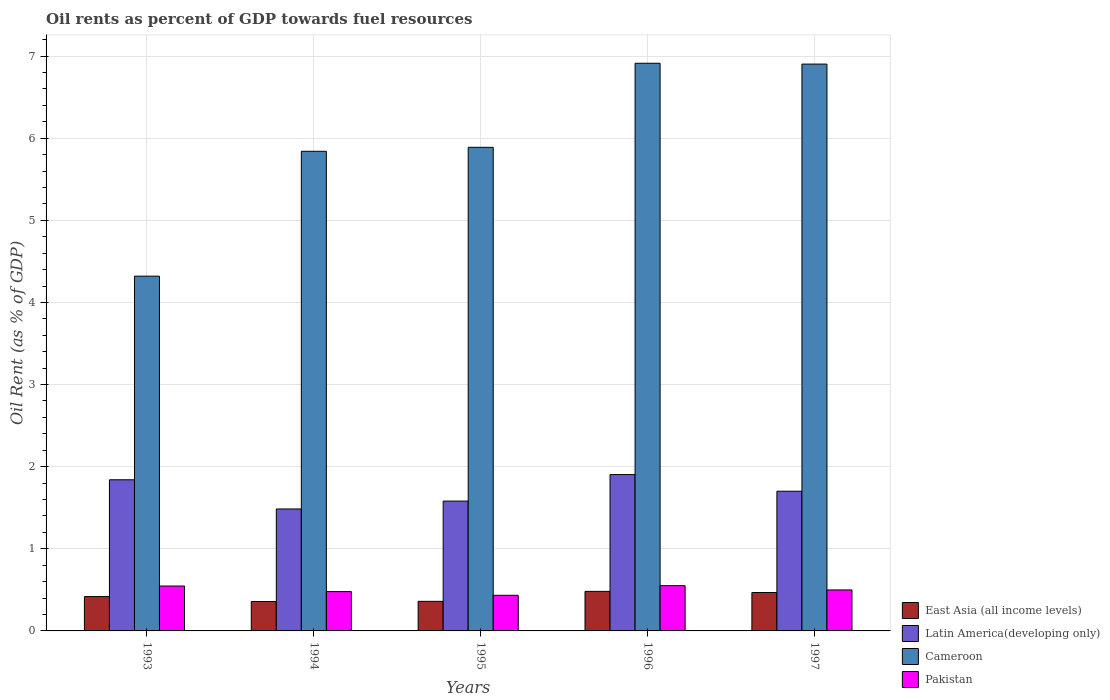How many different coloured bars are there?
Your answer should be very brief. 4. How many groups of bars are there?
Offer a terse response. 5. Are the number of bars per tick equal to the number of legend labels?
Provide a short and direct response. Yes. Are the number of bars on each tick of the X-axis equal?
Provide a short and direct response. Yes. How many bars are there on the 1st tick from the left?
Your answer should be compact. 4. What is the oil rent in Latin America(developing only) in 1993?
Ensure brevity in your answer.  1.84. Across all years, what is the maximum oil rent in East Asia (all income levels)?
Give a very brief answer. 0.48. Across all years, what is the minimum oil rent in East Asia (all income levels)?
Provide a succinct answer. 0.36. In which year was the oil rent in Latin America(developing only) maximum?
Give a very brief answer. 1996. In which year was the oil rent in Latin America(developing only) minimum?
Provide a succinct answer. 1994. What is the total oil rent in Pakistan in the graph?
Your answer should be very brief. 2.51. What is the difference between the oil rent in Cameroon in 1993 and that in 1994?
Your answer should be very brief. -1.52. What is the difference between the oil rent in East Asia (all income levels) in 1997 and the oil rent in Pakistan in 1996?
Keep it short and to the point. -0.08. What is the average oil rent in Pakistan per year?
Offer a terse response. 0.5. In the year 1996, what is the difference between the oil rent in Latin America(developing only) and oil rent in Cameroon?
Offer a very short reply. -5.01. In how many years, is the oil rent in East Asia (all income levels) greater than 6.2 %?
Keep it short and to the point. 0. What is the ratio of the oil rent in Latin America(developing only) in 1993 to that in 1994?
Your answer should be compact. 1.24. Is the difference between the oil rent in Latin America(developing only) in 1995 and 1997 greater than the difference between the oil rent in Cameroon in 1995 and 1997?
Keep it short and to the point. Yes. What is the difference between the highest and the second highest oil rent in Latin America(developing only)?
Give a very brief answer. 0.06. What is the difference between the highest and the lowest oil rent in East Asia (all income levels)?
Make the answer very short. 0.12. What does the 3rd bar from the left in 1997 represents?
Your answer should be compact. Cameroon. What does the 2nd bar from the right in 1993 represents?
Your answer should be very brief. Cameroon. Is it the case that in every year, the sum of the oil rent in Pakistan and oil rent in Latin America(developing only) is greater than the oil rent in Cameroon?
Give a very brief answer. No. How many bars are there?
Keep it short and to the point. 20. Are all the bars in the graph horizontal?
Give a very brief answer. No. What is the difference between two consecutive major ticks on the Y-axis?
Your answer should be compact. 1. Are the values on the major ticks of Y-axis written in scientific E-notation?
Offer a terse response. No. What is the title of the graph?
Your answer should be compact. Oil rents as percent of GDP towards fuel resources. What is the label or title of the X-axis?
Ensure brevity in your answer.  Years. What is the label or title of the Y-axis?
Offer a very short reply. Oil Rent (as % of GDP). What is the Oil Rent (as % of GDP) in East Asia (all income levels) in 1993?
Provide a short and direct response. 0.42. What is the Oil Rent (as % of GDP) in Latin America(developing only) in 1993?
Ensure brevity in your answer.  1.84. What is the Oil Rent (as % of GDP) in Cameroon in 1993?
Give a very brief answer. 4.32. What is the Oil Rent (as % of GDP) of Pakistan in 1993?
Ensure brevity in your answer.  0.55. What is the Oil Rent (as % of GDP) of East Asia (all income levels) in 1994?
Give a very brief answer. 0.36. What is the Oil Rent (as % of GDP) of Latin America(developing only) in 1994?
Your answer should be very brief. 1.49. What is the Oil Rent (as % of GDP) in Cameroon in 1994?
Provide a succinct answer. 5.84. What is the Oil Rent (as % of GDP) of Pakistan in 1994?
Offer a terse response. 0.48. What is the Oil Rent (as % of GDP) of East Asia (all income levels) in 1995?
Give a very brief answer. 0.36. What is the Oil Rent (as % of GDP) in Latin America(developing only) in 1995?
Provide a succinct answer. 1.58. What is the Oil Rent (as % of GDP) in Cameroon in 1995?
Your answer should be compact. 5.89. What is the Oil Rent (as % of GDP) in Pakistan in 1995?
Your answer should be compact. 0.43. What is the Oil Rent (as % of GDP) of East Asia (all income levels) in 1996?
Provide a succinct answer. 0.48. What is the Oil Rent (as % of GDP) in Latin America(developing only) in 1996?
Make the answer very short. 1.9. What is the Oil Rent (as % of GDP) of Cameroon in 1996?
Provide a succinct answer. 6.91. What is the Oil Rent (as % of GDP) of Pakistan in 1996?
Provide a succinct answer. 0.55. What is the Oil Rent (as % of GDP) of East Asia (all income levels) in 1997?
Provide a short and direct response. 0.47. What is the Oil Rent (as % of GDP) of Latin America(developing only) in 1997?
Your answer should be compact. 1.7. What is the Oil Rent (as % of GDP) of Cameroon in 1997?
Ensure brevity in your answer.  6.9. What is the Oil Rent (as % of GDP) in Pakistan in 1997?
Give a very brief answer. 0.5. Across all years, what is the maximum Oil Rent (as % of GDP) in East Asia (all income levels)?
Your answer should be compact. 0.48. Across all years, what is the maximum Oil Rent (as % of GDP) of Latin America(developing only)?
Provide a succinct answer. 1.9. Across all years, what is the maximum Oil Rent (as % of GDP) of Cameroon?
Your answer should be very brief. 6.91. Across all years, what is the maximum Oil Rent (as % of GDP) of Pakistan?
Give a very brief answer. 0.55. Across all years, what is the minimum Oil Rent (as % of GDP) in East Asia (all income levels)?
Your answer should be very brief. 0.36. Across all years, what is the minimum Oil Rent (as % of GDP) of Latin America(developing only)?
Your answer should be very brief. 1.49. Across all years, what is the minimum Oil Rent (as % of GDP) in Cameroon?
Your answer should be very brief. 4.32. Across all years, what is the minimum Oil Rent (as % of GDP) in Pakistan?
Your answer should be very brief. 0.43. What is the total Oil Rent (as % of GDP) of East Asia (all income levels) in the graph?
Your answer should be very brief. 2.09. What is the total Oil Rent (as % of GDP) in Latin America(developing only) in the graph?
Your response must be concise. 8.51. What is the total Oil Rent (as % of GDP) of Cameroon in the graph?
Make the answer very short. 29.86. What is the total Oil Rent (as % of GDP) of Pakistan in the graph?
Offer a very short reply. 2.51. What is the difference between the Oil Rent (as % of GDP) in East Asia (all income levels) in 1993 and that in 1994?
Provide a succinct answer. 0.06. What is the difference between the Oil Rent (as % of GDP) in Latin America(developing only) in 1993 and that in 1994?
Provide a succinct answer. 0.36. What is the difference between the Oil Rent (as % of GDP) in Cameroon in 1993 and that in 1994?
Provide a succinct answer. -1.52. What is the difference between the Oil Rent (as % of GDP) of Pakistan in 1993 and that in 1994?
Make the answer very short. 0.07. What is the difference between the Oil Rent (as % of GDP) of East Asia (all income levels) in 1993 and that in 1995?
Keep it short and to the point. 0.06. What is the difference between the Oil Rent (as % of GDP) of Latin America(developing only) in 1993 and that in 1995?
Your answer should be compact. 0.26. What is the difference between the Oil Rent (as % of GDP) in Cameroon in 1993 and that in 1995?
Ensure brevity in your answer.  -1.57. What is the difference between the Oil Rent (as % of GDP) of Pakistan in 1993 and that in 1995?
Your answer should be very brief. 0.11. What is the difference between the Oil Rent (as % of GDP) in East Asia (all income levels) in 1993 and that in 1996?
Provide a short and direct response. -0.06. What is the difference between the Oil Rent (as % of GDP) in Latin America(developing only) in 1993 and that in 1996?
Make the answer very short. -0.06. What is the difference between the Oil Rent (as % of GDP) of Cameroon in 1993 and that in 1996?
Offer a terse response. -2.59. What is the difference between the Oil Rent (as % of GDP) in Pakistan in 1993 and that in 1996?
Make the answer very short. -0. What is the difference between the Oil Rent (as % of GDP) of East Asia (all income levels) in 1993 and that in 1997?
Ensure brevity in your answer.  -0.05. What is the difference between the Oil Rent (as % of GDP) of Latin America(developing only) in 1993 and that in 1997?
Give a very brief answer. 0.14. What is the difference between the Oil Rent (as % of GDP) in Cameroon in 1993 and that in 1997?
Make the answer very short. -2.58. What is the difference between the Oil Rent (as % of GDP) in Pakistan in 1993 and that in 1997?
Provide a succinct answer. 0.05. What is the difference between the Oil Rent (as % of GDP) in East Asia (all income levels) in 1994 and that in 1995?
Give a very brief answer. -0. What is the difference between the Oil Rent (as % of GDP) of Latin America(developing only) in 1994 and that in 1995?
Ensure brevity in your answer.  -0.1. What is the difference between the Oil Rent (as % of GDP) of Cameroon in 1994 and that in 1995?
Give a very brief answer. -0.05. What is the difference between the Oil Rent (as % of GDP) in Pakistan in 1994 and that in 1995?
Provide a succinct answer. 0.04. What is the difference between the Oil Rent (as % of GDP) of East Asia (all income levels) in 1994 and that in 1996?
Offer a very short reply. -0.12. What is the difference between the Oil Rent (as % of GDP) of Latin America(developing only) in 1994 and that in 1996?
Offer a very short reply. -0.42. What is the difference between the Oil Rent (as % of GDP) of Cameroon in 1994 and that in 1996?
Keep it short and to the point. -1.07. What is the difference between the Oil Rent (as % of GDP) of Pakistan in 1994 and that in 1996?
Offer a very short reply. -0.07. What is the difference between the Oil Rent (as % of GDP) in East Asia (all income levels) in 1994 and that in 1997?
Your answer should be compact. -0.11. What is the difference between the Oil Rent (as % of GDP) in Latin America(developing only) in 1994 and that in 1997?
Keep it short and to the point. -0.22. What is the difference between the Oil Rent (as % of GDP) of Cameroon in 1994 and that in 1997?
Your response must be concise. -1.06. What is the difference between the Oil Rent (as % of GDP) in Pakistan in 1994 and that in 1997?
Your response must be concise. -0.02. What is the difference between the Oil Rent (as % of GDP) of East Asia (all income levels) in 1995 and that in 1996?
Ensure brevity in your answer.  -0.12. What is the difference between the Oil Rent (as % of GDP) of Latin America(developing only) in 1995 and that in 1996?
Provide a short and direct response. -0.32. What is the difference between the Oil Rent (as % of GDP) in Cameroon in 1995 and that in 1996?
Provide a short and direct response. -1.02. What is the difference between the Oil Rent (as % of GDP) of Pakistan in 1995 and that in 1996?
Ensure brevity in your answer.  -0.12. What is the difference between the Oil Rent (as % of GDP) of East Asia (all income levels) in 1995 and that in 1997?
Offer a terse response. -0.11. What is the difference between the Oil Rent (as % of GDP) in Latin America(developing only) in 1995 and that in 1997?
Offer a very short reply. -0.12. What is the difference between the Oil Rent (as % of GDP) in Cameroon in 1995 and that in 1997?
Your response must be concise. -1.01. What is the difference between the Oil Rent (as % of GDP) of Pakistan in 1995 and that in 1997?
Your response must be concise. -0.07. What is the difference between the Oil Rent (as % of GDP) of East Asia (all income levels) in 1996 and that in 1997?
Offer a terse response. 0.01. What is the difference between the Oil Rent (as % of GDP) of Latin America(developing only) in 1996 and that in 1997?
Give a very brief answer. 0.2. What is the difference between the Oil Rent (as % of GDP) in Cameroon in 1996 and that in 1997?
Your response must be concise. 0.01. What is the difference between the Oil Rent (as % of GDP) in Pakistan in 1996 and that in 1997?
Make the answer very short. 0.05. What is the difference between the Oil Rent (as % of GDP) of East Asia (all income levels) in 1993 and the Oil Rent (as % of GDP) of Latin America(developing only) in 1994?
Offer a terse response. -1.07. What is the difference between the Oil Rent (as % of GDP) in East Asia (all income levels) in 1993 and the Oil Rent (as % of GDP) in Cameroon in 1994?
Provide a succinct answer. -5.42. What is the difference between the Oil Rent (as % of GDP) in East Asia (all income levels) in 1993 and the Oil Rent (as % of GDP) in Pakistan in 1994?
Provide a succinct answer. -0.06. What is the difference between the Oil Rent (as % of GDP) in Latin America(developing only) in 1993 and the Oil Rent (as % of GDP) in Cameroon in 1994?
Your answer should be compact. -4. What is the difference between the Oil Rent (as % of GDP) in Latin America(developing only) in 1993 and the Oil Rent (as % of GDP) in Pakistan in 1994?
Your answer should be very brief. 1.36. What is the difference between the Oil Rent (as % of GDP) in Cameroon in 1993 and the Oil Rent (as % of GDP) in Pakistan in 1994?
Ensure brevity in your answer.  3.84. What is the difference between the Oil Rent (as % of GDP) of East Asia (all income levels) in 1993 and the Oil Rent (as % of GDP) of Latin America(developing only) in 1995?
Keep it short and to the point. -1.16. What is the difference between the Oil Rent (as % of GDP) in East Asia (all income levels) in 1993 and the Oil Rent (as % of GDP) in Cameroon in 1995?
Your response must be concise. -5.47. What is the difference between the Oil Rent (as % of GDP) in East Asia (all income levels) in 1993 and the Oil Rent (as % of GDP) in Pakistan in 1995?
Your answer should be very brief. -0.02. What is the difference between the Oil Rent (as % of GDP) of Latin America(developing only) in 1993 and the Oil Rent (as % of GDP) of Cameroon in 1995?
Your response must be concise. -4.05. What is the difference between the Oil Rent (as % of GDP) of Latin America(developing only) in 1993 and the Oil Rent (as % of GDP) of Pakistan in 1995?
Ensure brevity in your answer.  1.41. What is the difference between the Oil Rent (as % of GDP) of Cameroon in 1993 and the Oil Rent (as % of GDP) of Pakistan in 1995?
Make the answer very short. 3.89. What is the difference between the Oil Rent (as % of GDP) in East Asia (all income levels) in 1993 and the Oil Rent (as % of GDP) in Latin America(developing only) in 1996?
Provide a short and direct response. -1.49. What is the difference between the Oil Rent (as % of GDP) in East Asia (all income levels) in 1993 and the Oil Rent (as % of GDP) in Cameroon in 1996?
Your answer should be compact. -6.49. What is the difference between the Oil Rent (as % of GDP) of East Asia (all income levels) in 1993 and the Oil Rent (as % of GDP) of Pakistan in 1996?
Offer a terse response. -0.13. What is the difference between the Oil Rent (as % of GDP) of Latin America(developing only) in 1993 and the Oil Rent (as % of GDP) of Cameroon in 1996?
Offer a very short reply. -5.07. What is the difference between the Oil Rent (as % of GDP) in Latin America(developing only) in 1993 and the Oil Rent (as % of GDP) in Pakistan in 1996?
Offer a terse response. 1.29. What is the difference between the Oil Rent (as % of GDP) of Cameroon in 1993 and the Oil Rent (as % of GDP) of Pakistan in 1996?
Your answer should be compact. 3.77. What is the difference between the Oil Rent (as % of GDP) in East Asia (all income levels) in 1993 and the Oil Rent (as % of GDP) in Latin America(developing only) in 1997?
Your answer should be compact. -1.28. What is the difference between the Oil Rent (as % of GDP) in East Asia (all income levels) in 1993 and the Oil Rent (as % of GDP) in Cameroon in 1997?
Provide a succinct answer. -6.48. What is the difference between the Oil Rent (as % of GDP) in East Asia (all income levels) in 1993 and the Oil Rent (as % of GDP) in Pakistan in 1997?
Make the answer very short. -0.08. What is the difference between the Oil Rent (as % of GDP) of Latin America(developing only) in 1993 and the Oil Rent (as % of GDP) of Cameroon in 1997?
Give a very brief answer. -5.06. What is the difference between the Oil Rent (as % of GDP) in Latin America(developing only) in 1993 and the Oil Rent (as % of GDP) in Pakistan in 1997?
Keep it short and to the point. 1.34. What is the difference between the Oil Rent (as % of GDP) in Cameroon in 1993 and the Oil Rent (as % of GDP) in Pakistan in 1997?
Give a very brief answer. 3.82. What is the difference between the Oil Rent (as % of GDP) of East Asia (all income levels) in 1994 and the Oil Rent (as % of GDP) of Latin America(developing only) in 1995?
Your response must be concise. -1.22. What is the difference between the Oil Rent (as % of GDP) of East Asia (all income levels) in 1994 and the Oil Rent (as % of GDP) of Cameroon in 1995?
Provide a short and direct response. -5.53. What is the difference between the Oil Rent (as % of GDP) of East Asia (all income levels) in 1994 and the Oil Rent (as % of GDP) of Pakistan in 1995?
Ensure brevity in your answer.  -0.08. What is the difference between the Oil Rent (as % of GDP) of Latin America(developing only) in 1994 and the Oil Rent (as % of GDP) of Cameroon in 1995?
Your response must be concise. -4.4. What is the difference between the Oil Rent (as % of GDP) in Latin America(developing only) in 1994 and the Oil Rent (as % of GDP) in Pakistan in 1995?
Offer a very short reply. 1.05. What is the difference between the Oil Rent (as % of GDP) of Cameroon in 1994 and the Oil Rent (as % of GDP) of Pakistan in 1995?
Provide a succinct answer. 5.41. What is the difference between the Oil Rent (as % of GDP) of East Asia (all income levels) in 1994 and the Oil Rent (as % of GDP) of Latin America(developing only) in 1996?
Your answer should be compact. -1.55. What is the difference between the Oil Rent (as % of GDP) of East Asia (all income levels) in 1994 and the Oil Rent (as % of GDP) of Cameroon in 1996?
Your answer should be compact. -6.55. What is the difference between the Oil Rent (as % of GDP) in East Asia (all income levels) in 1994 and the Oil Rent (as % of GDP) in Pakistan in 1996?
Your answer should be very brief. -0.19. What is the difference between the Oil Rent (as % of GDP) in Latin America(developing only) in 1994 and the Oil Rent (as % of GDP) in Cameroon in 1996?
Your response must be concise. -5.43. What is the difference between the Oil Rent (as % of GDP) of Latin America(developing only) in 1994 and the Oil Rent (as % of GDP) of Pakistan in 1996?
Provide a short and direct response. 0.93. What is the difference between the Oil Rent (as % of GDP) in Cameroon in 1994 and the Oil Rent (as % of GDP) in Pakistan in 1996?
Your response must be concise. 5.29. What is the difference between the Oil Rent (as % of GDP) of East Asia (all income levels) in 1994 and the Oil Rent (as % of GDP) of Latin America(developing only) in 1997?
Provide a short and direct response. -1.34. What is the difference between the Oil Rent (as % of GDP) of East Asia (all income levels) in 1994 and the Oil Rent (as % of GDP) of Cameroon in 1997?
Offer a very short reply. -6.54. What is the difference between the Oil Rent (as % of GDP) in East Asia (all income levels) in 1994 and the Oil Rent (as % of GDP) in Pakistan in 1997?
Provide a succinct answer. -0.14. What is the difference between the Oil Rent (as % of GDP) of Latin America(developing only) in 1994 and the Oil Rent (as % of GDP) of Cameroon in 1997?
Keep it short and to the point. -5.42. What is the difference between the Oil Rent (as % of GDP) of Latin America(developing only) in 1994 and the Oil Rent (as % of GDP) of Pakistan in 1997?
Your answer should be compact. 0.99. What is the difference between the Oil Rent (as % of GDP) in Cameroon in 1994 and the Oil Rent (as % of GDP) in Pakistan in 1997?
Give a very brief answer. 5.34. What is the difference between the Oil Rent (as % of GDP) in East Asia (all income levels) in 1995 and the Oil Rent (as % of GDP) in Latin America(developing only) in 1996?
Offer a very short reply. -1.54. What is the difference between the Oil Rent (as % of GDP) in East Asia (all income levels) in 1995 and the Oil Rent (as % of GDP) in Cameroon in 1996?
Make the answer very short. -6.55. What is the difference between the Oil Rent (as % of GDP) of East Asia (all income levels) in 1995 and the Oil Rent (as % of GDP) of Pakistan in 1996?
Your answer should be compact. -0.19. What is the difference between the Oil Rent (as % of GDP) in Latin America(developing only) in 1995 and the Oil Rent (as % of GDP) in Cameroon in 1996?
Your answer should be very brief. -5.33. What is the difference between the Oil Rent (as % of GDP) in Latin America(developing only) in 1995 and the Oil Rent (as % of GDP) in Pakistan in 1996?
Provide a short and direct response. 1.03. What is the difference between the Oil Rent (as % of GDP) of Cameroon in 1995 and the Oil Rent (as % of GDP) of Pakistan in 1996?
Your answer should be compact. 5.34. What is the difference between the Oil Rent (as % of GDP) of East Asia (all income levels) in 1995 and the Oil Rent (as % of GDP) of Latin America(developing only) in 1997?
Your answer should be very brief. -1.34. What is the difference between the Oil Rent (as % of GDP) in East Asia (all income levels) in 1995 and the Oil Rent (as % of GDP) in Cameroon in 1997?
Provide a short and direct response. -6.54. What is the difference between the Oil Rent (as % of GDP) in East Asia (all income levels) in 1995 and the Oil Rent (as % of GDP) in Pakistan in 1997?
Your answer should be very brief. -0.14. What is the difference between the Oil Rent (as % of GDP) in Latin America(developing only) in 1995 and the Oil Rent (as % of GDP) in Cameroon in 1997?
Your response must be concise. -5.32. What is the difference between the Oil Rent (as % of GDP) in Latin America(developing only) in 1995 and the Oil Rent (as % of GDP) in Pakistan in 1997?
Your response must be concise. 1.08. What is the difference between the Oil Rent (as % of GDP) of Cameroon in 1995 and the Oil Rent (as % of GDP) of Pakistan in 1997?
Make the answer very short. 5.39. What is the difference between the Oil Rent (as % of GDP) of East Asia (all income levels) in 1996 and the Oil Rent (as % of GDP) of Latin America(developing only) in 1997?
Your response must be concise. -1.22. What is the difference between the Oil Rent (as % of GDP) of East Asia (all income levels) in 1996 and the Oil Rent (as % of GDP) of Cameroon in 1997?
Ensure brevity in your answer.  -6.42. What is the difference between the Oil Rent (as % of GDP) in East Asia (all income levels) in 1996 and the Oil Rent (as % of GDP) in Pakistan in 1997?
Provide a short and direct response. -0.02. What is the difference between the Oil Rent (as % of GDP) in Latin America(developing only) in 1996 and the Oil Rent (as % of GDP) in Cameroon in 1997?
Give a very brief answer. -5. What is the difference between the Oil Rent (as % of GDP) in Latin America(developing only) in 1996 and the Oil Rent (as % of GDP) in Pakistan in 1997?
Offer a terse response. 1.4. What is the difference between the Oil Rent (as % of GDP) of Cameroon in 1996 and the Oil Rent (as % of GDP) of Pakistan in 1997?
Your answer should be very brief. 6.41. What is the average Oil Rent (as % of GDP) of East Asia (all income levels) per year?
Your response must be concise. 0.42. What is the average Oil Rent (as % of GDP) of Latin America(developing only) per year?
Your answer should be very brief. 1.7. What is the average Oil Rent (as % of GDP) of Cameroon per year?
Provide a short and direct response. 5.97. What is the average Oil Rent (as % of GDP) of Pakistan per year?
Make the answer very short. 0.5. In the year 1993, what is the difference between the Oil Rent (as % of GDP) of East Asia (all income levels) and Oil Rent (as % of GDP) of Latin America(developing only)?
Offer a very short reply. -1.42. In the year 1993, what is the difference between the Oil Rent (as % of GDP) of East Asia (all income levels) and Oil Rent (as % of GDP) of Cameroon?
Provide a short and direct response. -3.9. In the year 1993, what is the difference between the Oil Rent (as % of GDP) of East Asia (all income levels) and Oil Rent (as % of GDP) of Pakistan?
Provide a short and direct response. -0.13. In the year 1993, what is the difference between the Oil Rent (as % of GDP) of Latin America(developing only) and Oil Rent (as % of GDP) of Cameroon?
Your answer should be very brief. -2.48. In the year 1993, what is the difference between the Oil Rent (as % of GDP) of Latin America(developing only) and Oil Rent (as % of GDP) of Pakistan?
Your response must be concise. 1.29. In the year 1993, what is the difference between the Oil Rent (as % of GDP) of Cameroon and Oil Rent (as % of GDP) of Pakistan?
Your answer should be very brief. 3.77. In the year 1994, what is the difference between the Oil Rent (as % of GDP) in East Asia (all income levels) and Oil Rent (as % of GDP) in Latin America(developing only)?
Keep it short and to the point. -1.13. In the year 1994, what is the difference between the Oil Rent (as % of GDP) of East Asia (all income levels) and Oil Rent (as % of GDP) of Cameroon?
Ensure brevity in your answer.  -5.48. In the year 1994, what is the difference between the Oil Rent (as % of GDP) of East Asia (all income levels) and Oil Rent (as % of GDP) of Pakistan?
Offer a terse response. -0.12. In the year 1994, what is the difference between the Oil Rent (as % of GDP) of Latin America(developing only) and Oil Rent (as % of GDP) of Cameroon?
Your answer should be compact. -4.36. In the year 1994, what is the difference between the Oil Rent (as % of GDP) in Latin America(developing only) and Oil Rent (as % of GDP) in Pakistan?
Your answer should be compact. 1.01. In the year 1994, what is the difference between the Oil Rent (as % of GDP) in Cameroon and Oil Rent (as % of GDP) in Pakistan?
Your answer should be compact. 5.36. In the year 1995, what is the difference between the Oil Rent (as % of GDP) of East Asia (all income levels) and Oil Rent (as % of GDP) of Latin America(developing only)?
Your response must be concise. -1.22. In the year 1995, what is the difference between the Oil Rent (as % of GDP) in East Asia (all income levels) and Oil Rent (as % of GDP) in Cameroon?
Offer a very short reply. -5.53. In the year 1995, what is the difference between the Oil Rent (as % of GDP) of East Asia (all income levels) and Oil Rent (as % of GDP) of Pakistan?
Offer a very short reply. -0.07. In the year 1995, what is the difference between the Oil Rent (as % of GDP) in Latin America(developing only) and Oil Rent (as % of GDP) in Cameroon?
Keep it short and to the point. -4.31. In the year 1995, what is the difference between the Oil Rent (as % of GDP) in Latin America(developing only) and Oil Rent (as % of GDP) in Pakistan?
Your answer should be compact. 1.15. In the year 1995, what is the difference between the Oil Rent (as % of GDP) of Cameroon and Oil Rent (as % of GDP) of Pakistan?
Keep it short and to the point. 5.45. In the year 1996, what is the difference between the Oil Rent (as % of GDP) in East Asia (all income levels) and Oil Rent (as % of GDP) in Latin America(developing only)?
Provide a succinct answer. -1.42. In the year 1996, what is the difference between the Oil Rent (as % of GDP) in East Asia (all income levels) and Oil Rent (as % of GDP) in Cameroon?
Give a very brief answer. -6.43. In the year 1996, what is the difference between the Oil Rent (as % of GDP) of East Asia (all income levels) and Oil Rent (as % of GDP) of Pakistan?
Your response must be concise. -0.07. In the year 1996, what is the difference between the Oil Rent (as % of GDP) in Latin America(developing only) and Oil Rent (as % of GDP) in Cameroon?
Make the answer very short. -5.01. In the year 1996, what is the difference between the Oil Rent (as % of GDP) of Latin America(developing only) and Oil Rent (as % of GDP) of Pakistan?
Provide a succinct answer. 1.35. In the year 1996, what is the difference between the Oil Rent (as % of GDP) of Cameroon and Oil Rent (as % of GDP) of Pakistan?
Keep it short and to the point. 6.36. In the year 1997, what is the difference between the Oil Rent (as % of GDP) in East Asia (all income levels) and Oil Rent (as % of GDP) in Latin America(developing only)?
Your answer should be very brief. -1.23. In the year 1997, what is the difference between the Oil Rent (as % of GDP) of East Asia (all income levels) and Oil Rent (as % of GDP) of Cameroon?
Keep it short and to the point. -6.43. In the year 1997, what is the difference between the Oil Rent (as % of GDP) in East Asia (all income levels) and Oil Rent (as % of GDP) in Pakistan?
Provide a succinct answer. -0.03. In the year 1997, what is the difference between the Oil Rent (as % of GDP) in Latin America(developing only) and Oil Rent (as % of GDP) in Cameroon?
Offer a terse response. -5.2. In the year 1997, what is the difference between the Oil Rent (as % of GDP) in Latin America(developing only) and Oil Rent (as % of GDP) in Pakistan?
Provide a short and direct response. 1.2. In the year 1997, what is the difference between the Oil Rent (as % of GDP) in Cameroon and Oil Rent (as % of GDP) in Pakistan?
Offer a very short reply. 6.4. What is the ratio of the Oil Rent (as % of GDP) in East Asia (all income levels) in 1993 to that in 1994?
Keep it short and to the point. 1.17. What is the ratio of the Oil Rent (as % of GDP) in Latin America(developing only) in 1993 to that in 1994?
Your answer should be compact. 1.24. What is the ratio of the Oil Rent (as % of GDP) in Cameroon in 1993 to that in 1994?
Keep it short and to the point. 0.74. What is the ratio of the Oil Rent (as % of GDP) of Pakistan in 1993 to that in 1994?
Provide a succinct answer. 1.14. What is the ratio of the Oil Rent (as % of GDP) of East Asia (all income levels) in 1993 to that in 1995?
Your answer should be very brief. 1.16. What is the ratio of the Oil Rent (as % of GDP) in Latin America(developing only) in 1993 to that in 1995?
Your answer should be compact. 1.16. What is the ratio of the Oil Rent (as % of GDP) in Cameroon in 1993 to that in 1995?
Your answer should be compact. 0.73. What is the ratio of the Oil Rent (as % of GDP) of Pakistan in 1993 to that in 1995?
Keep it short and to the point. 1.26. What is the ratio of the Oil Rent (as % of GDP) in East Asia (all income levels) in 1993 to that in 1996?
Give a very brief answer. 0.87. What is the ratio of the Oil Rent (as % of GDP) in Latin America(developing only) in 1993 to that in 1996?
Offer a very short reply. 0.97. What is the ratio of the Oil Rent (as % of GDP) in Cameroon in 1993 to that in 1996?
Your answer should be very brief. 0.62. What is the ratio of the Oil Rent (as % of GDP) in Pakistan in 1993 to that in 1996?
Your answer should be very brief. 0.99. What is the ratio of the Oil Rent (as % of GDP) of East Asia (all income levels) in 1993 to that in 1997?
Keep it short and to the point. 0.89. What is the ratio of the Oil Rent (as % of GDP) in Latin America(developing only) in 1993 to that in 1997?
Offer a very short reply. 1.08. What is the ratio of the Oil Rent (as % of GDP) of Cameroon in 1993 to that in 1997?
Your answer should be compact. 0.63. What is the ratio of the Oil Rent (as % of GDP) in Pakistan in 1993 to that in 1997?
Provide a short and direct response. 1.1. What is the ratio of the Oil Rent (as % of GDP) in Latin America(developing only) in 1994 to that in 1995?
Offer a terse response. 0.94. What is the ratio of the Oil Rent (as % of GDP) of Pakistan in 1994 to that in 1995?
Your response must be concise. 1.1. What is the ratio of the Oil Rent (as % of GDP) in East Asia (all income levels) in 1994 to that in 1996?
Your answer should be very brief. 0.74. What is the ratio of the Oil Rent (as % of GDP) of Latin America(developing only) in 1994 to that in 1996?
Ensure brevity in your answer.  0.78. What is the ratio of the Oil Rent (as % of GDP) of Cameroon in 1994 to that in 1996?
Offer a terse response. 0.84. What is the ratio of the Oil Rent (as % of GDP) of Pakistan in 1994 to that in 1996?
Offer a very short reply. 0.87. What is the ratio of the Oil Rent (as % of GDP) in East Asia (all income levels) in 1994 to that in 1997?
Your answer should be very brief. 0.77. What is the ratio of the Oil Rent (as % of GDP) in Latin America(developing only) in 1994 to that in 1997?
Make the answer very short. 0.87. What is the ratio of the Oil Rent (as % of GDP) of Cameroon in 1994 to that in 1997?
Your answer should be very brief. 0.85. What is the ratio of the Oil Rent (as % of GDP) of Pakistan in 1994 to that in 1997?
Your answer should be compact. 0.96. What is the ratio of the Oil Rent (as % of GDP) in East Asia (all income levels) in 1995 to that in 1996?
Ensure brevity in your answer.  0.75. What is the ratio of the Oil Rent (as % of GDP) in Latin America(developing only) in 1995 to that in 1996?
Provide a short and direct response. 0.83. What is the ratio of the Oil Rent (as % of GDP) in Cameroon in 1995 to that in 1996?
Provide a short and direct response. 0.85. What is the ratio of the Oil Rent (as % of GDP) of Pakistan in 1995 to that in 1996?
Your response must be concise. 0.79. What is the ratio of the Oil Rent (as % of GDP) in East Asia (all income levels) in 1995 to that in 1997?
Offer a terse response. 0.77. What is the ratio of the Oil Rent (as % of GDP) of Latin America(developing only) in 1995 to that in 1997?
Your response must be concise. 0.93. What is the ratio of the Oil Rent (as % of GDP) of Cameroon in 1995 to that in 1997?
Offer a very short reply. 0.85. What is the ratio of the Oil Rent (as % of GDP) in Pakistan in 1995 to that in 1997?
Keep it short and to the point. 0.87. What is the ratio of the Oil Rent (as % of GDP) in East Asia (all income levels) in 1996 to that in 1997?
Keep it short and to the point. 1.03. What is the ratio of the Oil Rent (as % of GDP) in Latin America(developing only) in 1996 to that in 1997?
Give a very brief answer. 1.12. What is the ratio of the Oil Rent (as % of GDP) of Pakistan in 1996 to that in 1997?
Provide a short and direct response. 1.1. What is the difference between the highest and the second highest Oil Rent (as % of GDP) of East Asia (all income levels)?
Offer a very short reply. 0.01. What is the difference between the highest and the second highest Oil Rent (as % of GDP) of Latin America(developing only)?
Keep it short and to the point. 0.06. What is the difference between the highest and the second highest Oil Rent (as % of GDP) in Cameroon?
Your answer should be very brief. 0.01. What is the difference between the highest and the second highest Oil Rent (as % of GDP) in Pakistan?
Your answer should be very brief. 0. What is the difference between the highest and the lowest Oil Rent (as % of GDP) in East Asia (all income levels)?
Your answer should be very brief. 0.12. What is the difference between the highest and the lowest Oil Rent (as % of GDP) of Latin America(developing only)?
Ensure brevity in your answer.  0.42. What is the difference between the highest and the lowest Oil Rent (as % of GDP) of Cameroon?
Your answer should be compact. 2.59. What is the difference between the highest and the lowest Oil Rent (as % of GDP) in Pakistan?
Offer a terse response. 0.12. 